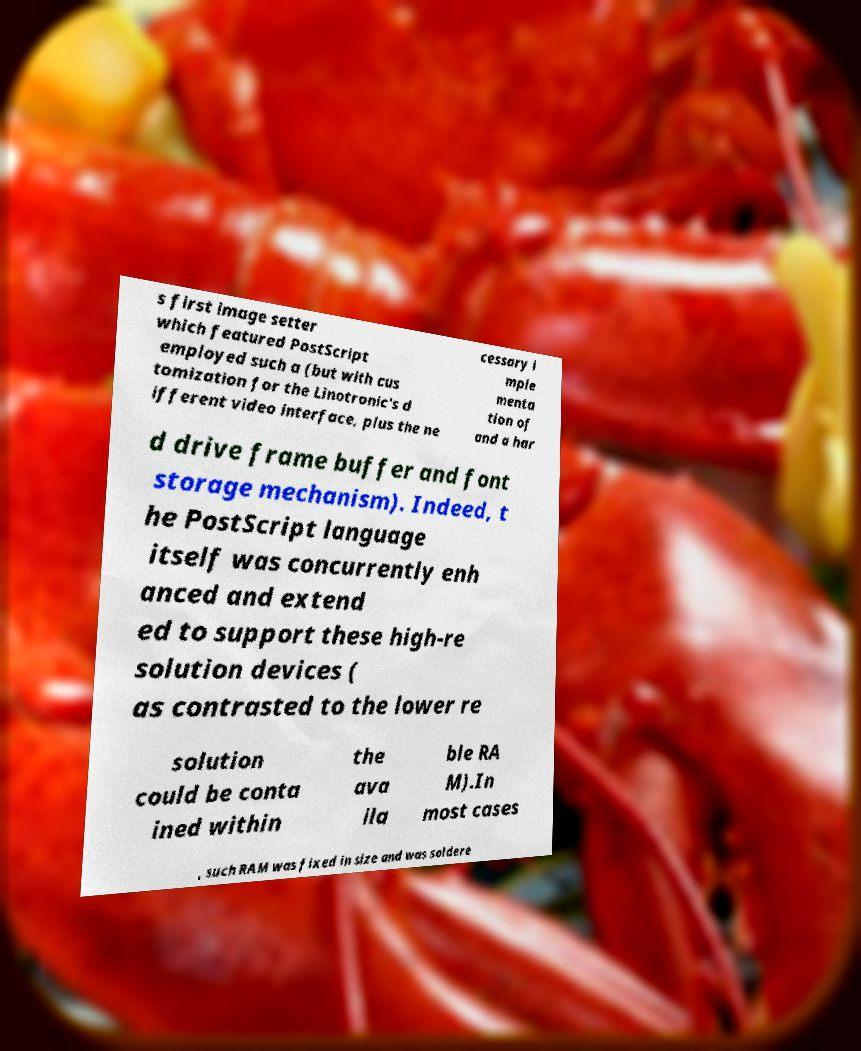Please identify and transcribe the text found in this image. s first image setter which featured PostScript employed such a (but with cus tomization for the Linotronic's d ifferent video interface, plus the ne cessary i mple menta tion of and a har d drive frame buffer and font storage mechanism). Indeed, t he PostScript language itself was concurrently enh anced and extend ed to support these high-re solution devices ( as contrasted to the lower re solution could be conta ined within the ava ila ble RA M).In most cases , such RAM was fixed in size and was soldere 